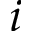Convert formula to latex. <formula><loc_0><loc_0><loc_500><loc_500>i</formula> 